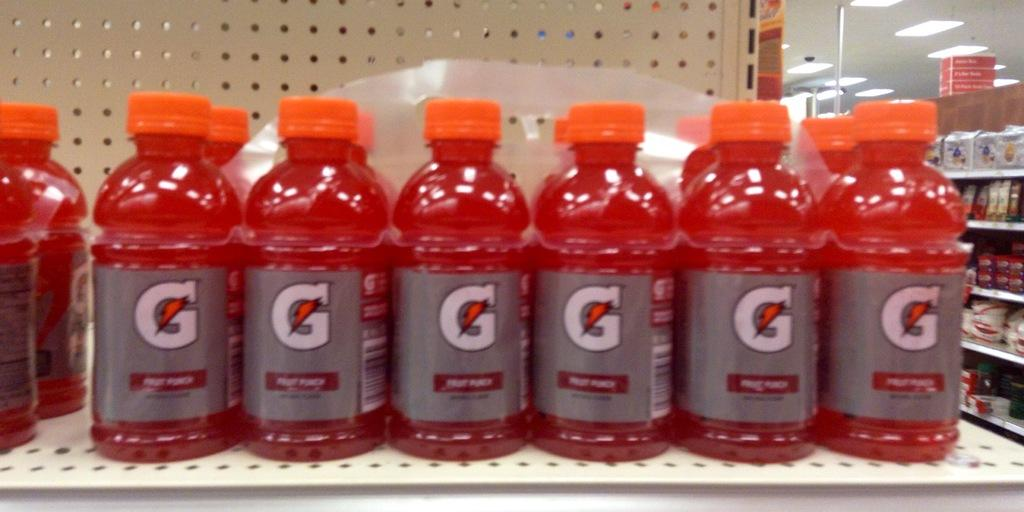<image>
Describe the image concisely. Many bottles of red Fruit Punch Gatorade are on a shelf. 